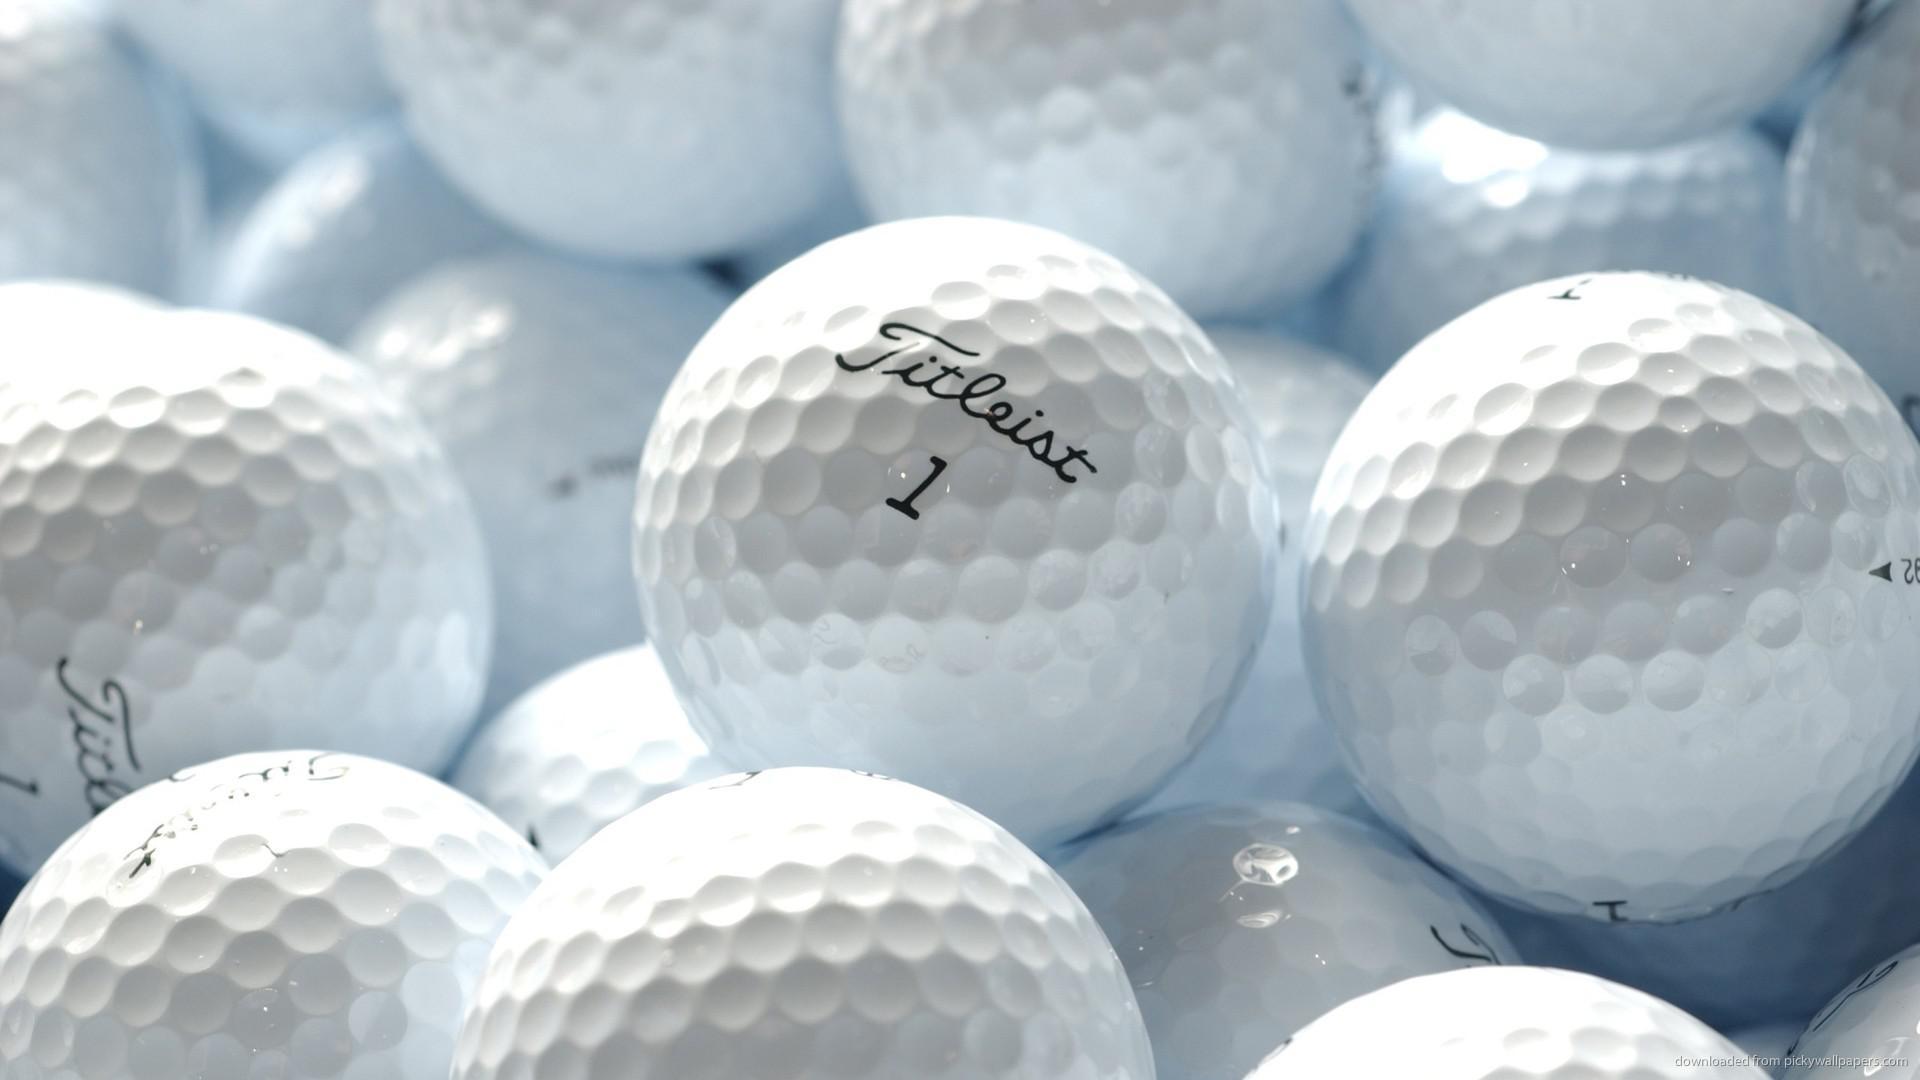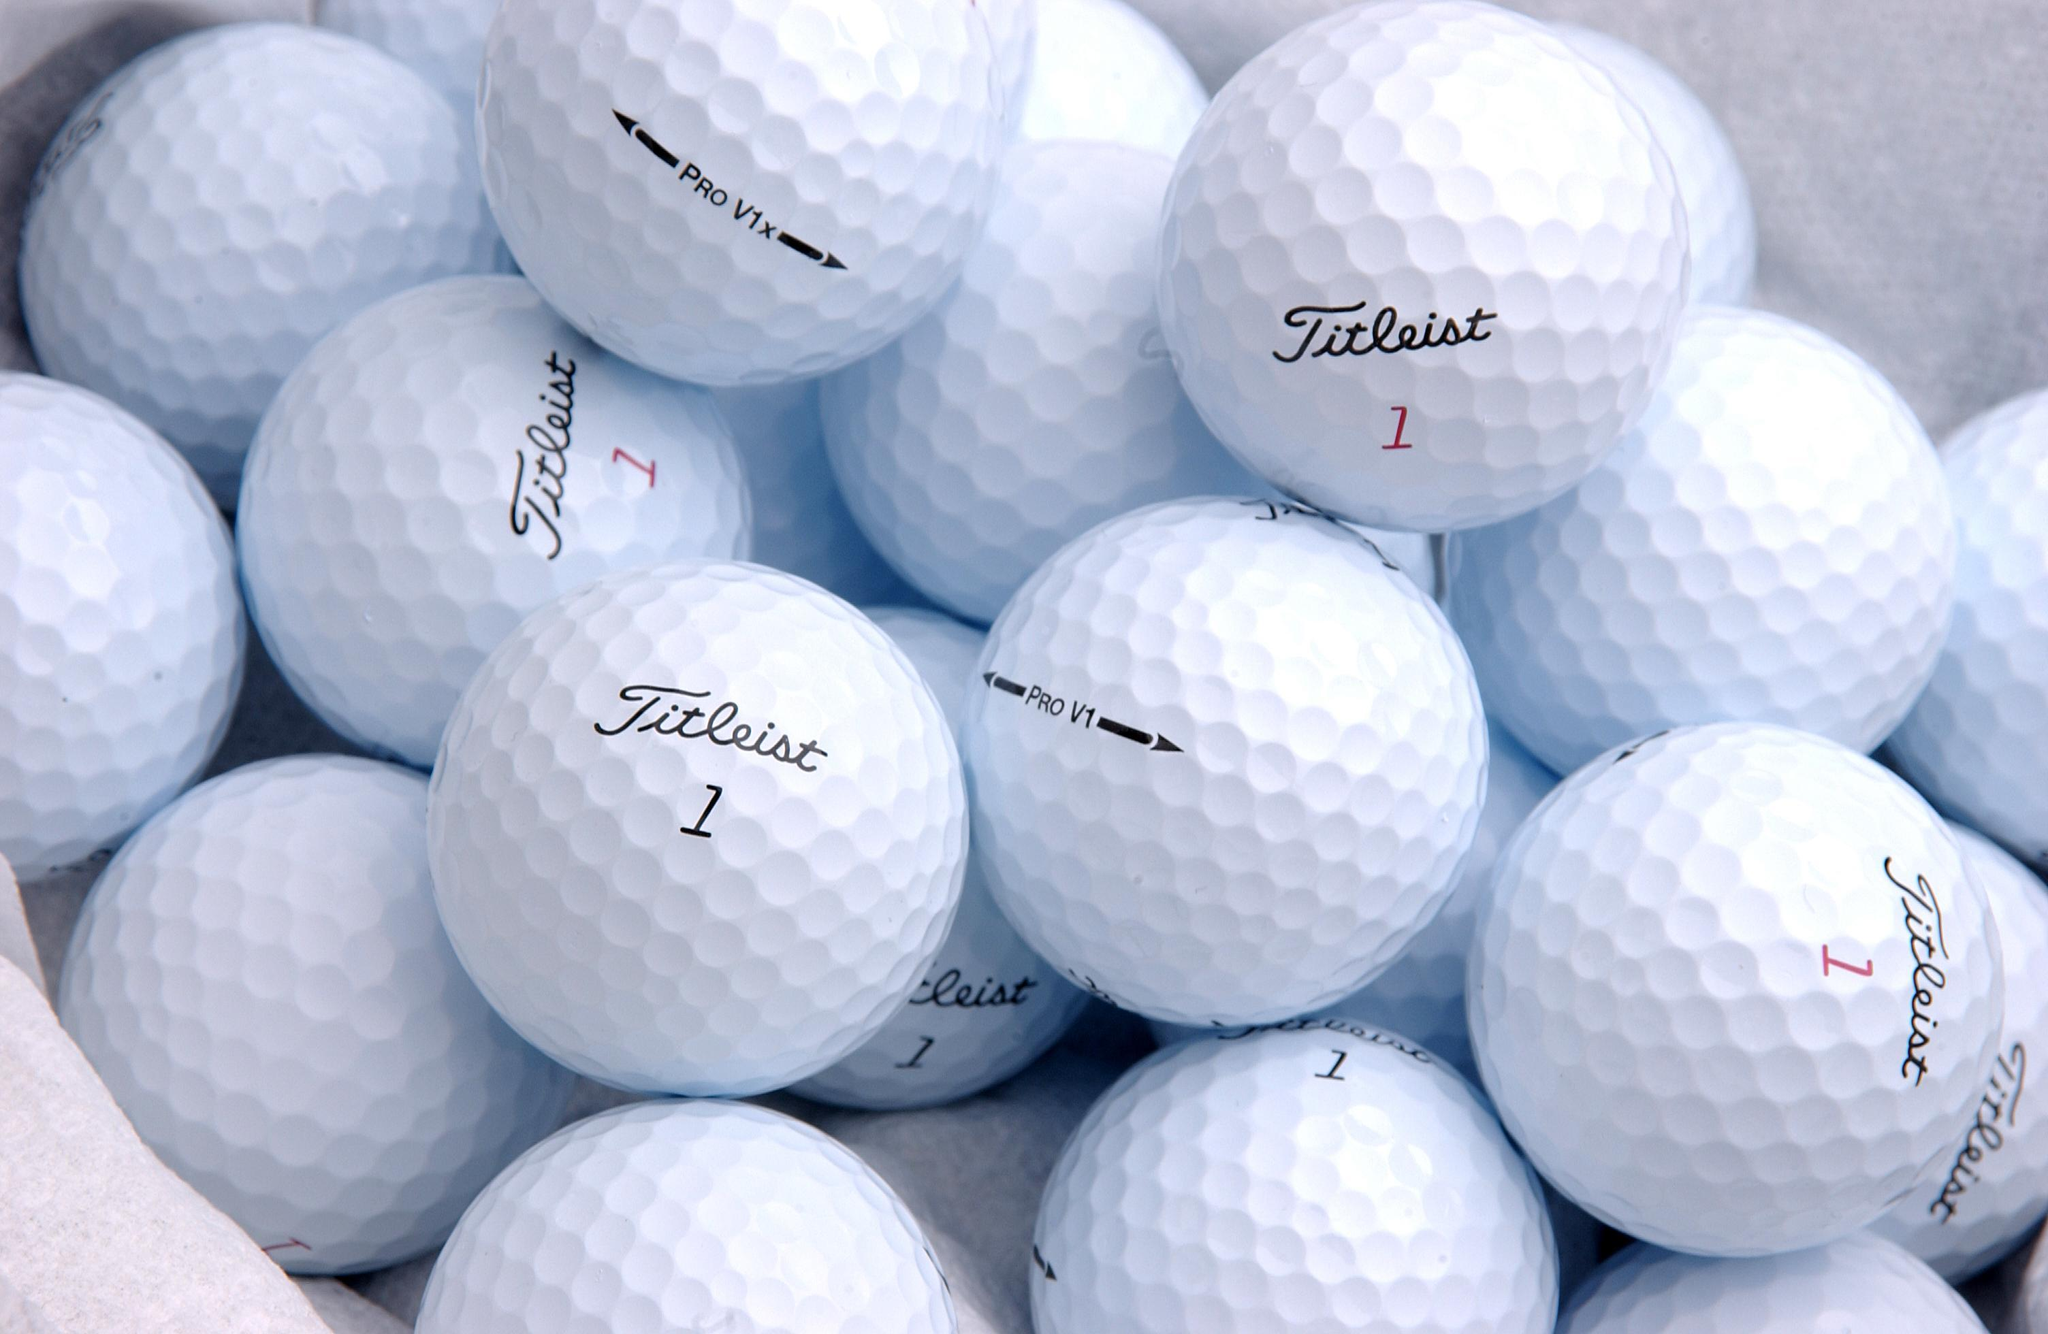The first image is the image on the left, the second image is the image on the right. Considering the images on both sides, is "There are exactly two golf balls" valid? Answer yes or no. No. 